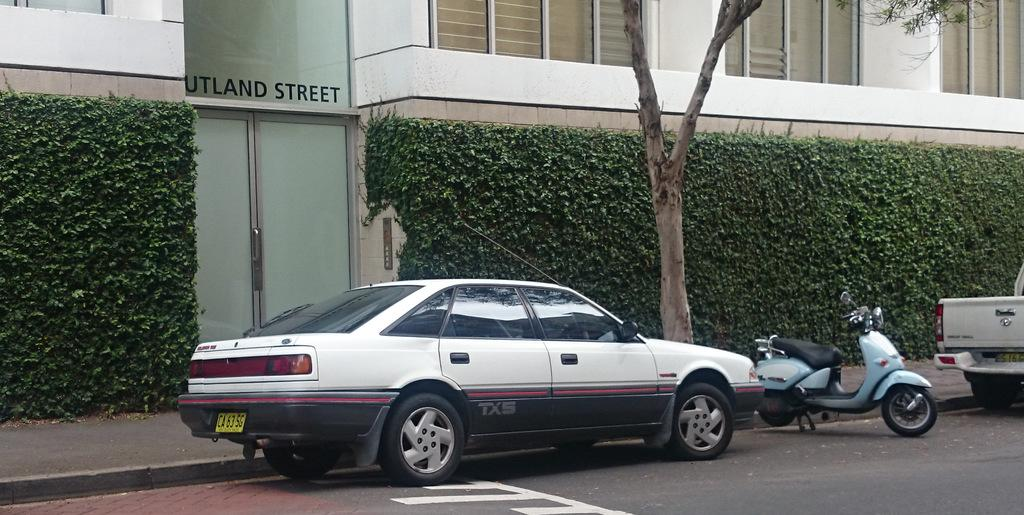What types of vehicles are in the image? There are cars and a bike in the image. Where are the cars and bike located? The cars and bike are on a road in the image. What can be seen in the background of the image? There is a building, a hedge, and a tree in the background of the image. What features of the building are visible in the image? There is a door and windows in the image. What type of account is being discussed in the image? There is no account being discussed in the image; it features cars, a bike, a road, and a building. Can you see any curves in the image? There are no curves explicitly mentioned or visible in the image. 